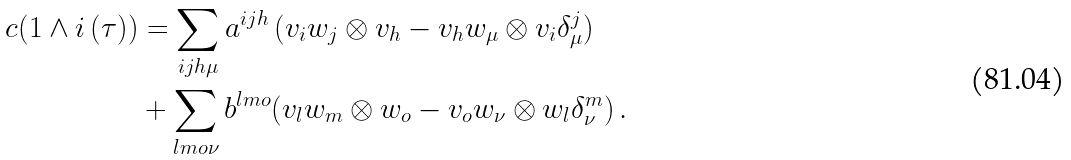Convert formula to latex. <formula><loc_0><loc_0><loc_500><loc_500>c ( 1 \wedge i \, ( \tau ) ) & = \sum _ { i j h \mu } a ^ { i j h } \, ( v _ { i } w _ { j } \otimes v _ { h } - v _ { h } w _ { \mu } \otimes v _ { i } \delta ^ { j } _ { \mu } ) \\ & + \sum _ { l m o \nu } b ^ { l m o } ( v _ { l } w _ { m } \otimes w _ { o } - v _ { o } w _ { \nu } \otimes w _ { l } \delta ^ { m } _ { \nu } ) \, .</formula> 